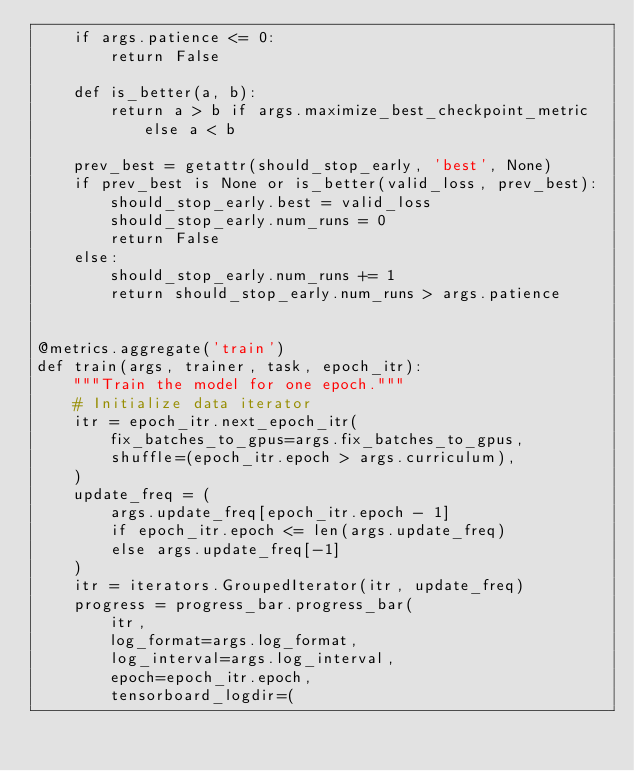Convert code to text. <code><loc_0><loc_0><loc_500><loc_500><_Python_>    if args.patience <= 0:
        return False

    def is_better(a, b):
        return a > b if args.maximize_best_checkpoint_metric else a < b

    prev_best = getattr(should_stop_early, 'best', None)
    if prev_best is None or is_better(valid_loss, prev_best):
        should_stop_early.best = valid_loss
        should_stop_early.num_runs = 0
        return False
    else:
        should_stop_early.num_runs += 1
        return should_stop_early.num_runs > args.patience


@metrics.aggregate('train')
def train(args, trainer, task, epoch_itr):
    """Train the model for one epoch."""
    # Initialize data iterator
    itr = epoch_itr.next_epoch_itr(
        fix_batches_to_gpus=args.fix_batches_to_gpus,
        shuffle=(epoch_itr.epoch > args.curriculum),
    )
    update_freq = (
        args.update_freq[epoch_itr.epoch - 1]
        if epoch_itr.epoch <= len(args.update_freq)
        else args.update_freq[-1]
    )
    itr = iterators.GroupedIterator(itr, update_freq)
    progress = progress_bar.progress_bar(
        itr,
        log_format=args.log_format,
        log_interval=args.log_interval,
        epoch=epoch_itr.epoch,
        tensorboard_logdir=(</code> 